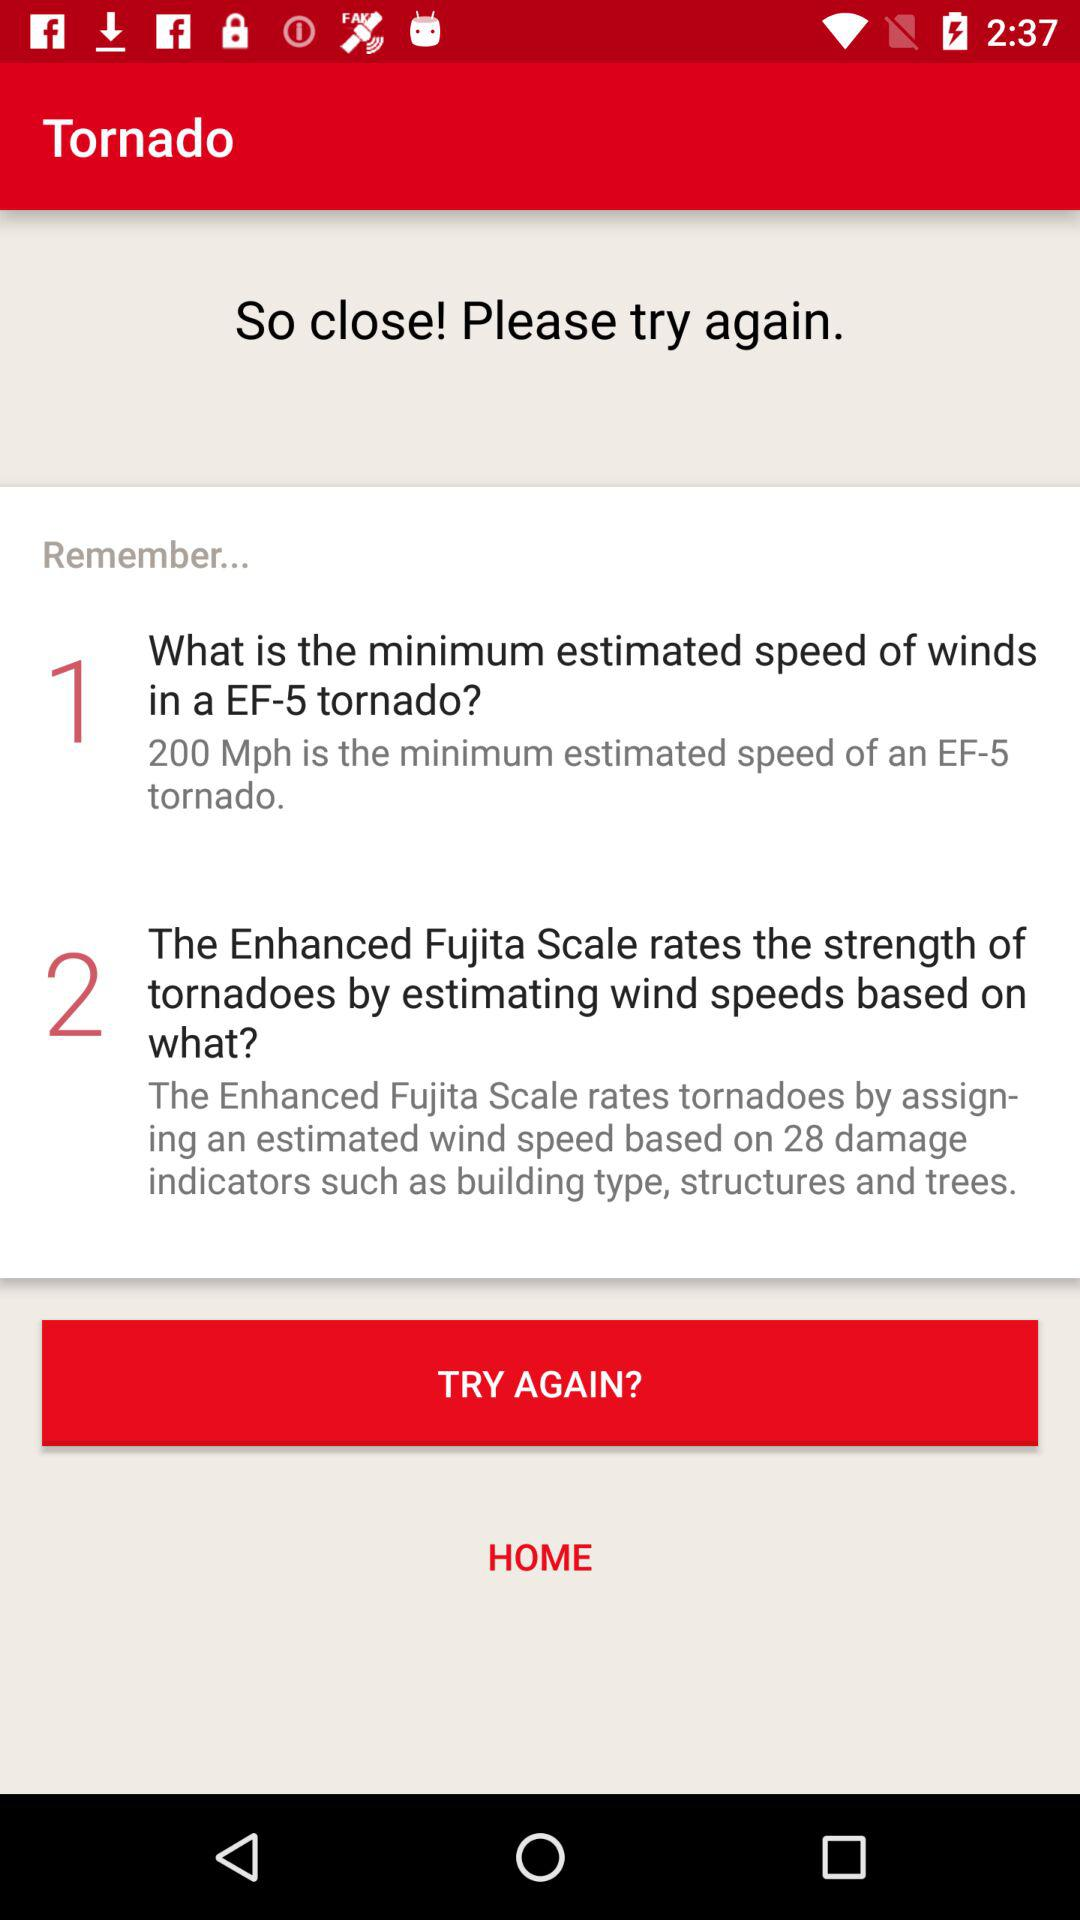What is the application name? The application name is "Tornado". 